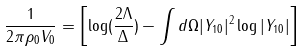Convert formula to latex. <formula><loc_0><loc_0><loc_500><loc_500>\frac { 1 } { 2 \pi \rho _ { 0 } V _ { 0 } } = \left [ \log ( \frac { 2 \Lambda } { \Delta } ) - \int d \Omega | Y _ { 1 0 } | ^ { 2 } \log | Y _ { 1 0 } | \right ]</formula> 